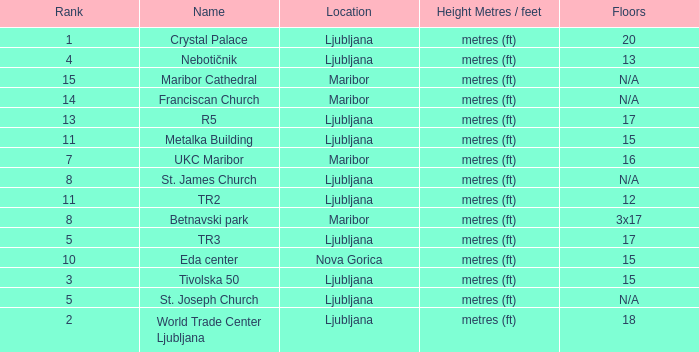Which Name has a Location of ljubljana? Crystal Palace, World Trade Center Ljubljana, Tivolska 50, Nebotičnik, TR3, St. Joseph Church, St. James Church, Metalka Building, TR2, R5. 